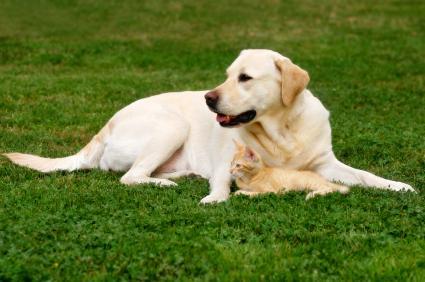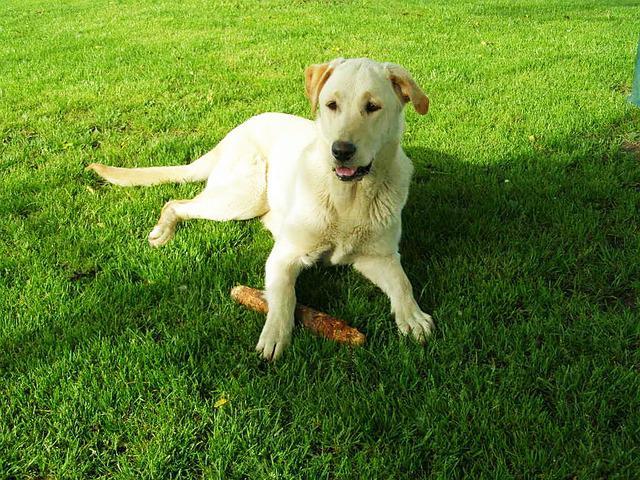The first image is the image on the left, the second image is the image on the right. Analyze the images presented: Is the assertion "A large stick-like object is on the grass near a dog in one image." valid? Answer yes or no. Yes. 